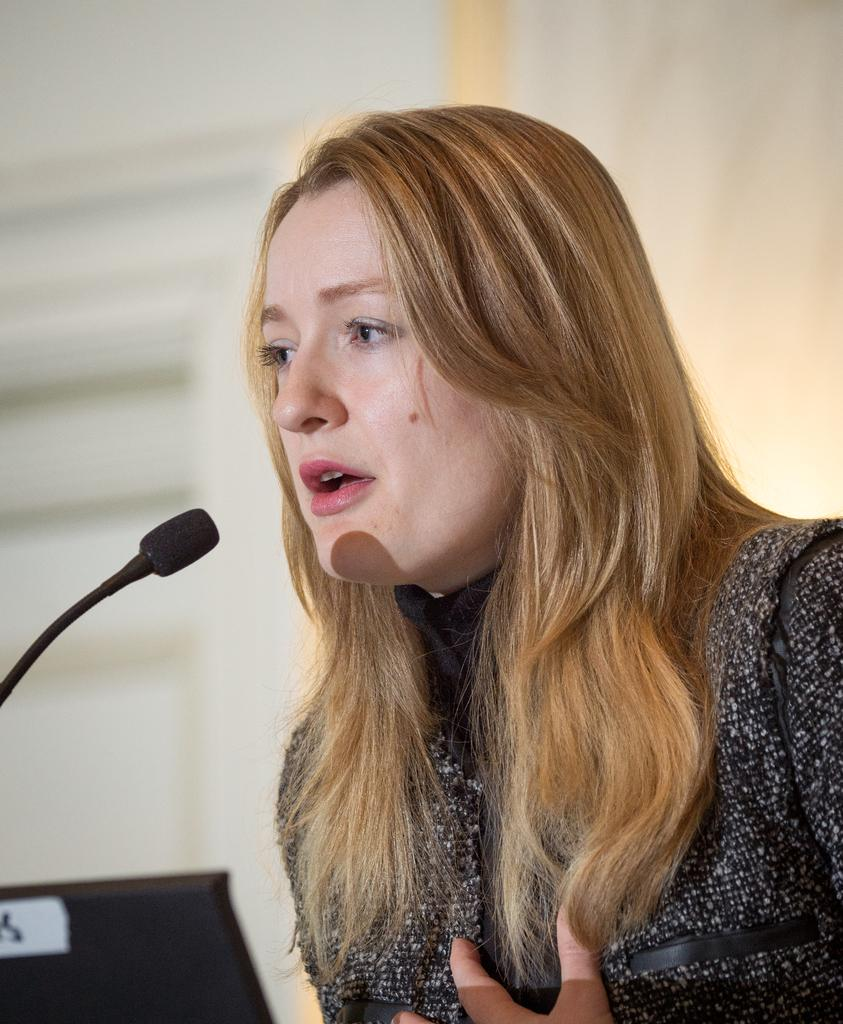What object is present in the image that is commonly used for amplifying sound? There is a microphone in the image. What electronic device can be seen in the image? There is a laptop in the image. Who is present in the image? There is a woman in the image. What color is the dress the woman is wearing? The woman is wearing a black dress. What can be seen in the background of the image? There is a wall in the background of the image. What type of table is visible in the image? There is no table present in the image. What season is depicted in the image? The image does not depict a specific season, as there are no seasonal cues present. 